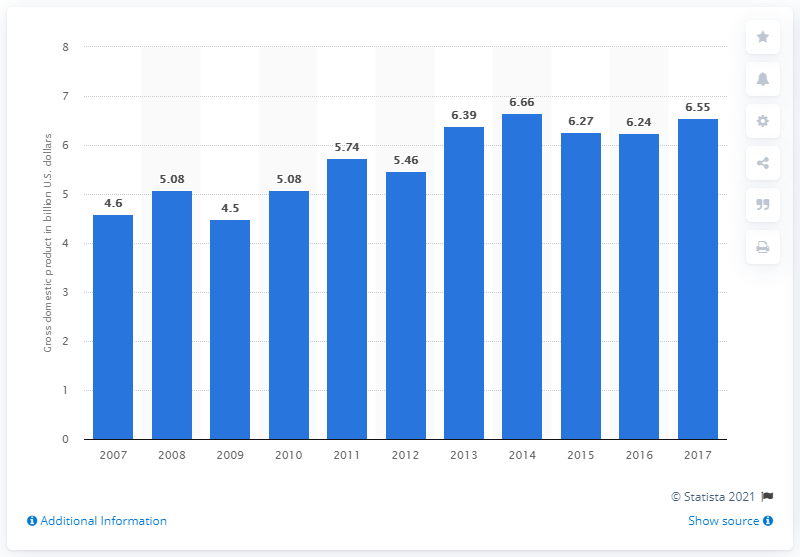Identify some key points in this picture. In 2017, the gross domestic product of Liechtenstein was 6.55. 